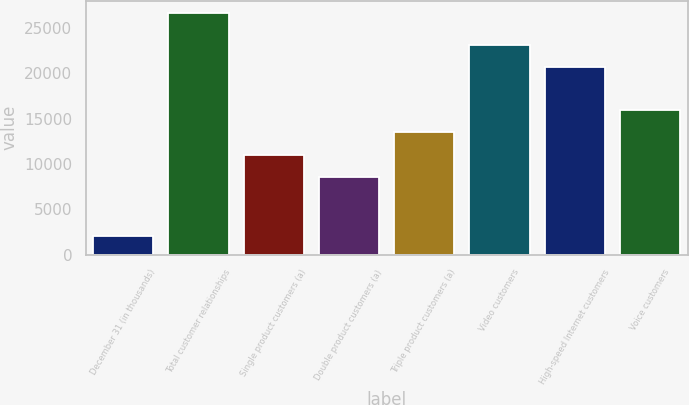Convert chart to OTSL. <chart><loc_0><loc_0><loc_500><loc_500><bar_chart><fcel>December 31 (in thousands)<fcel>Total customer relationships<fcel>Single product customers (a)<fcel>Double product customers (a)<fcel>Triple product customers (a)<fcel>Video customers<fcel>High-speed Internet customers<fcel>Voice customers<nl><fcel>2013<fcel>26677<fcel>11007.4<fcel>8541<fcel>13473.8<fcel>23151.4<fcel>20685<fcel>15940.2<nl></chart> 